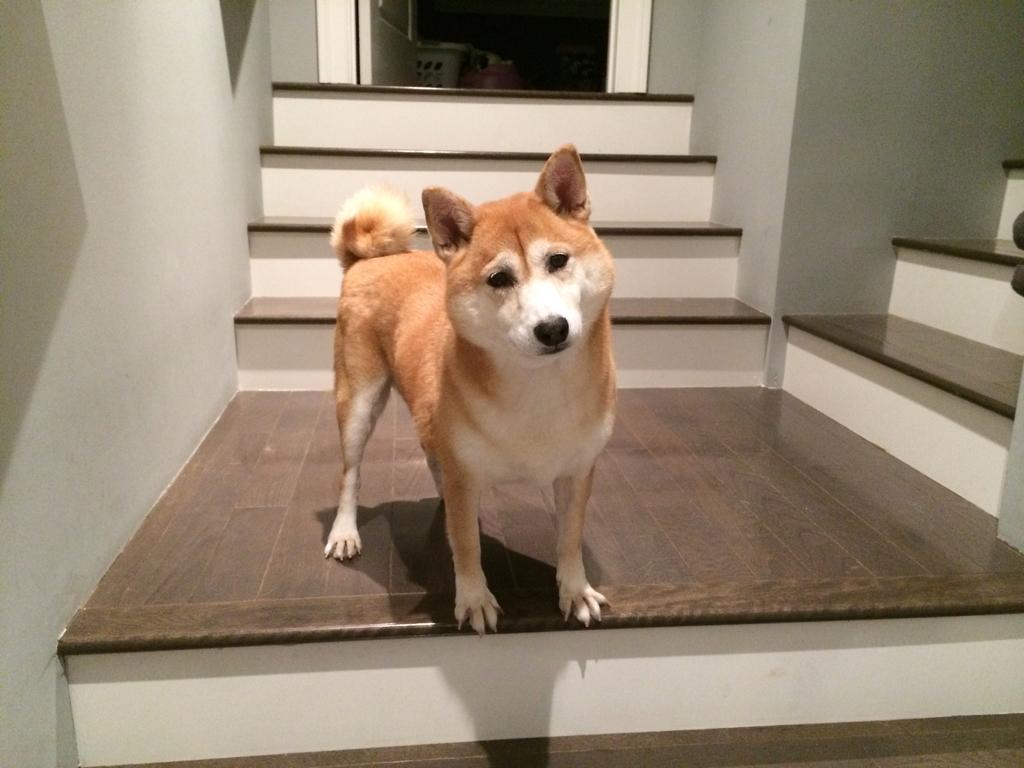Please provide a concise description of this image. In this image we can see a dog which is of brown and white color standing on the stairs and at the background of the image there is door. 